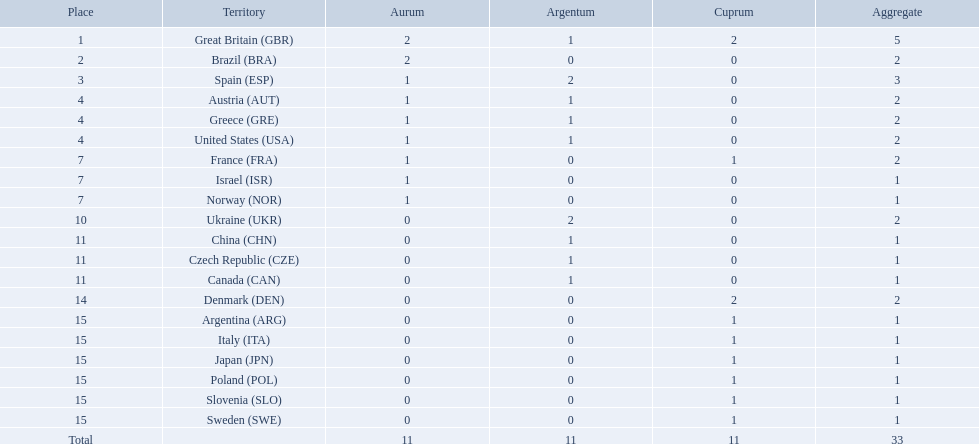Which nation received 2 silver medals? Spain (ESP), Ukraine (UKR). Would you mind parsing the complete table? {'header': ['Place', 'Territory', 'Aurum', 'Argentum', 'Cuprum', 'Aggregate'], 'rows': [['1', 'Great Britain\xa0(GBR)', '2', '1', '2', '5'], ['2', 'Brazil\xa0(BRA)', '2', '0', '0', '2'], ['3', 'Spain\xa0(ESP)', '1', '2', '0', '3'], ['4', 'Austria\xa0(AUT)', '1', '1', '0', '2'], ['4', 'Greece\xa0(GRE)', '1', '1', '0', '2'], ['4', 'United States\xa0(USA)', '1', '1', '0', '2'], ['7', 'France\xa0(FRA)', '1', '0', '1', '2'], ['7', 'Israel\xa0(ISR)', '1', '0', '0', '1'], ['7', 'Norway\xa0(NOR)', '1', '0', '0', '1'], ['10', 'Ukraine\xa0(UKR)', '0', '2', '0', '2'], ['11', 'China\xa0(CHN)', '0', '1', '0', '1'], ['11', 'Czech Republic\xa0(CZE)', '0', '1', '0', '1'], ['11', 'Canada\xa0(CAN)', '0', '1', '0', '1'], ['14', 'Denmark\xa0(DEN)', '0', '0', '2', '2'], ['15', 'Argentina\xa0(ARG)', '0', '0', '1', '1'], ['15', 'Italy\xa0(ITA)', '0', '0', '1', '1'], ['15', 'Japan\xa0(JPN)', '0', '0', '1', '1'], ['15', 'Poland\xa0(POL)', '0', '0', '1', '1'], ['15', 'Slovenia\xa0(SLO)', '0', '0', '1', '1'], ['15', 'Sweden\xa0(SWE)', '0', '0', '1', '1'], ['Total', '', '11', '11', '11', '33']]} Of those, which nation also had 2 total medals? Spain (ESP). 